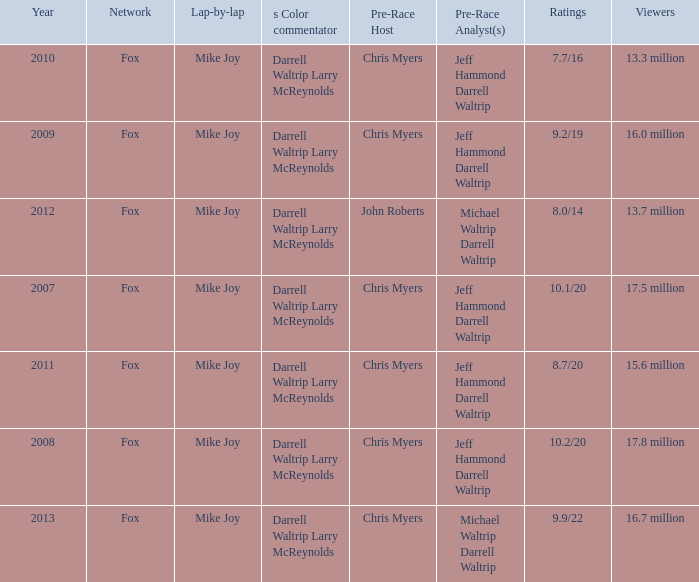Which Network has 17.5 million Viewers? Fox. 